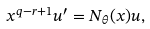Convert formula to latex. <formula><loc_0><loc_0><loc_500><loc_500>x ^ { q - r + 1 } u ^ { \prime } = N _ { \theta } ( x ) u ,</formula> 